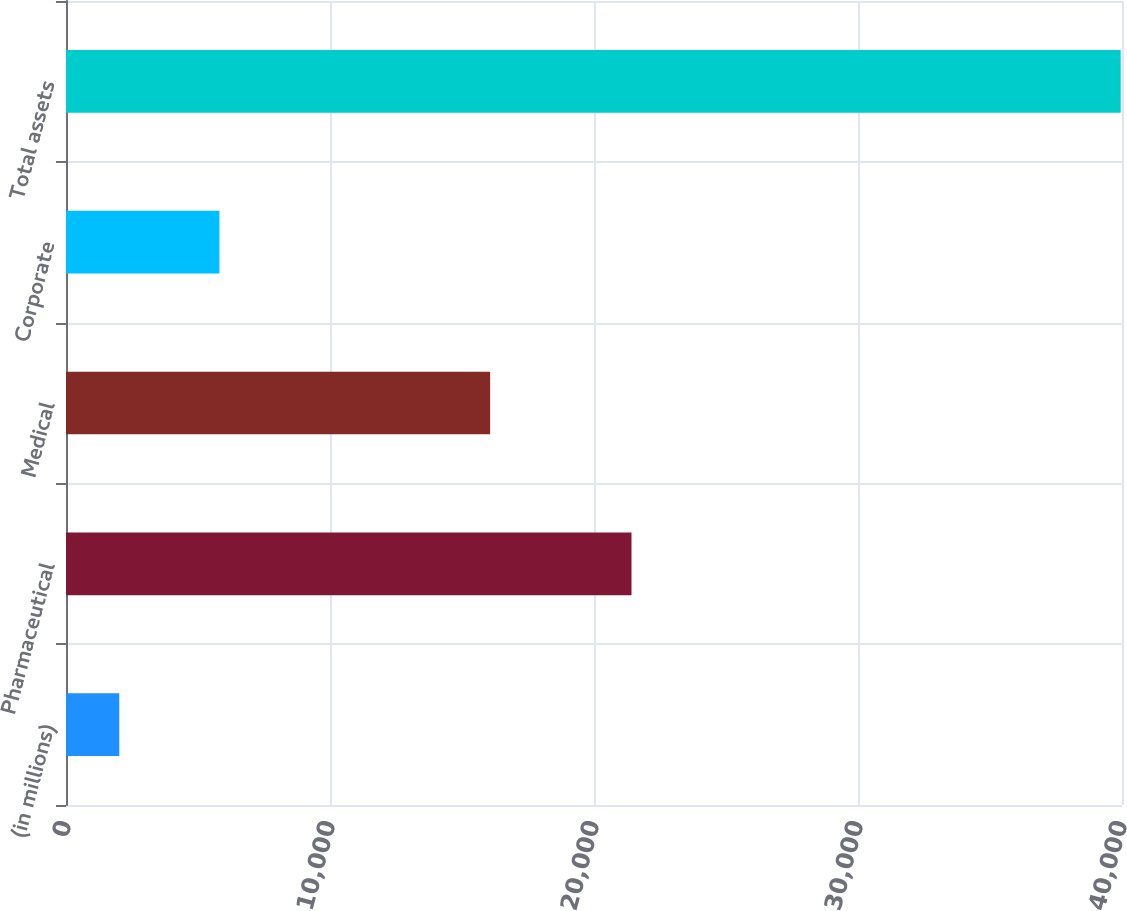Convert chart to OTSL. <chart><loc_0><loc_0><loc_500><loc_500><bar_chart><fcel>(in millions)<fcel>Pharmaceutical<fcel>Medical<fcel>Corporate<fcel>Total assets<nl><fcel>2018<fcel>21421<fcel>16066<fcel>5811.3<fcel>39951<nl></chart> 